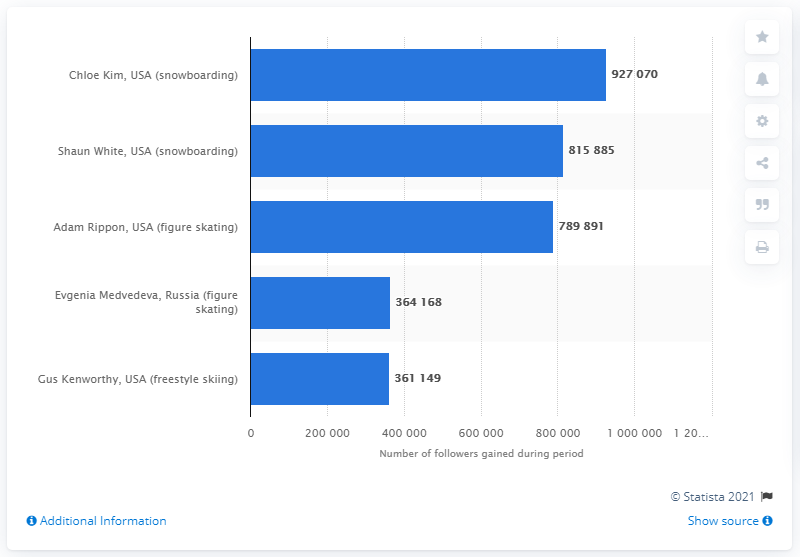Point out several critical features in this image. Chloe Kim, a renowned snowboarder from the USA, is the most popular athlete in the chart. Four athletes in the charts are from the United States. 